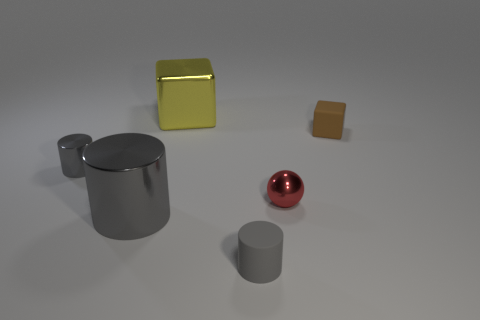What number of other objects are there of the same material as the brown block?
Your response must be concise. 1. What number of rubber objects are either tiny red objects or small things?
Offer a terse response. 2. Is the number of tiny red metal balls less than the number of things?
Your response must be concise. Yes. There is a gray rubber thing; is its size the same as the block that is on the left side of the small block?
Offer a terse response. No. Are there any other things that have the same shape as the tiny gray metallic thing?
Keep it short and to the point. Yes. How big is the matte cylinder?
Your answer should be compact. Small. Are there fewer spheres left of the small shiny sphere than red metallic objects?
Provide a succinct answer. Yes. Do the matte cylinder and the yellow metallic cube have the same size?
Offer a very short reply. No. Are there any other things that are the same size as the red metallic sphere?
Your response must be concise. Yes. What is the color of the other large object that is made of the same material as the yellow thing?
Ensure brevity in your answer.  Gray. 